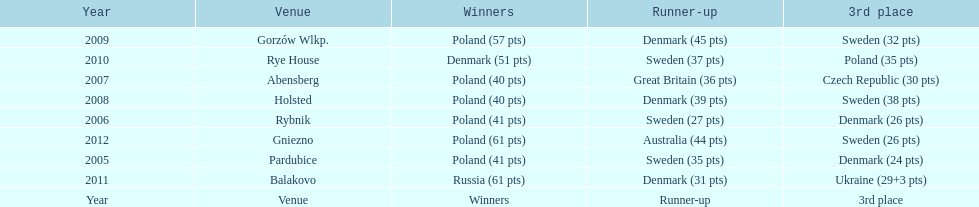When was the first year that poland did not place in the top three positions of the team speedway junior world championship? 2011. 